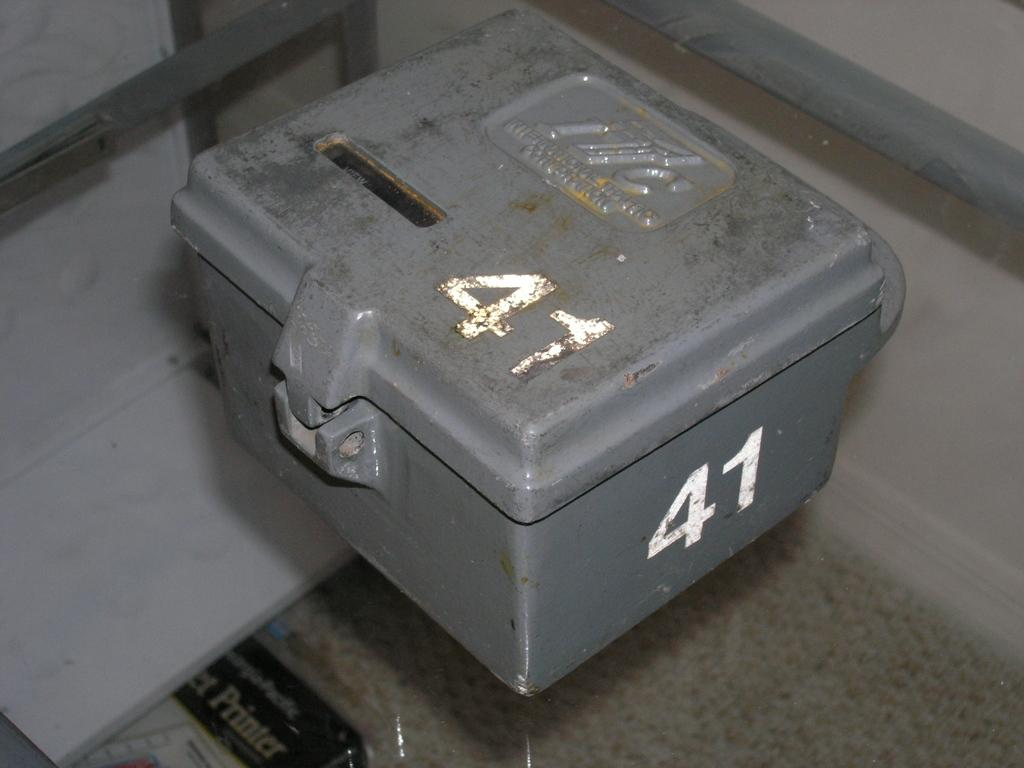<image>
Provide a brief description of the given image. The steel box number 41 is closed but not locked. 